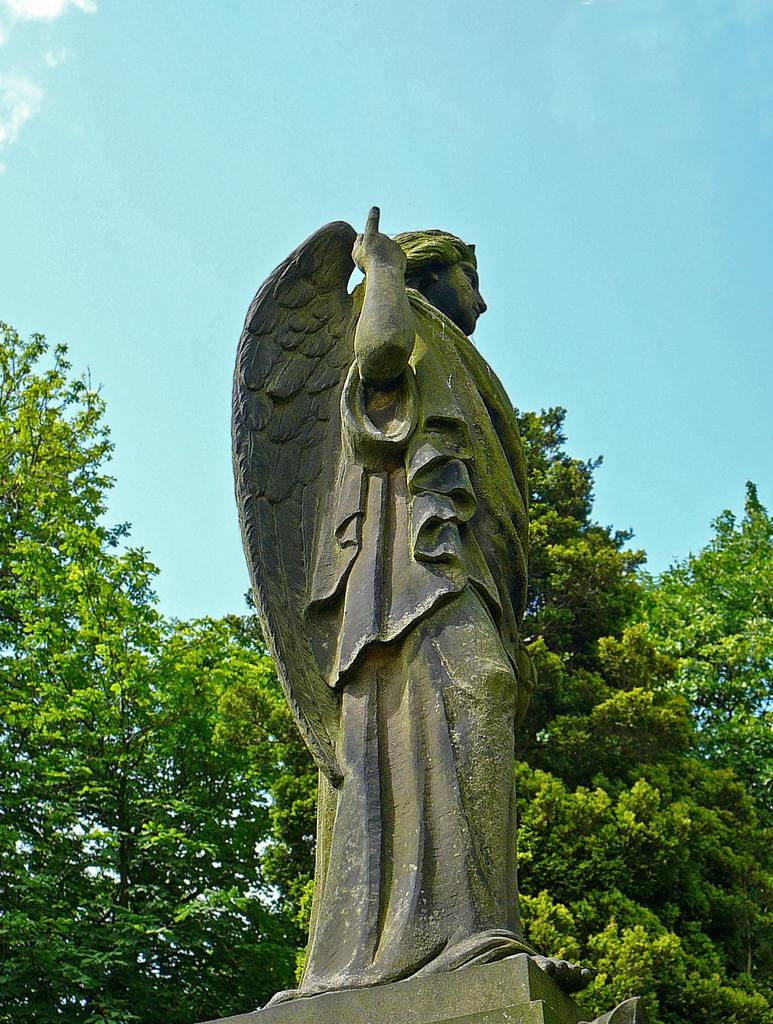What is the main subject of the image? There is a sculpture in the image. What can be seen in the background of the image? There are trees and clouds visible in the background of the image. What part of the natural environment is visible in the image? The sky is visible in the background of the image. What type of desk can be seen in the image? There is no desk present in the image; it features a sculpture and natural elements in the background. What act is the maid performing in the image? There is no maid present in the image, and therefore no act can be observed. 